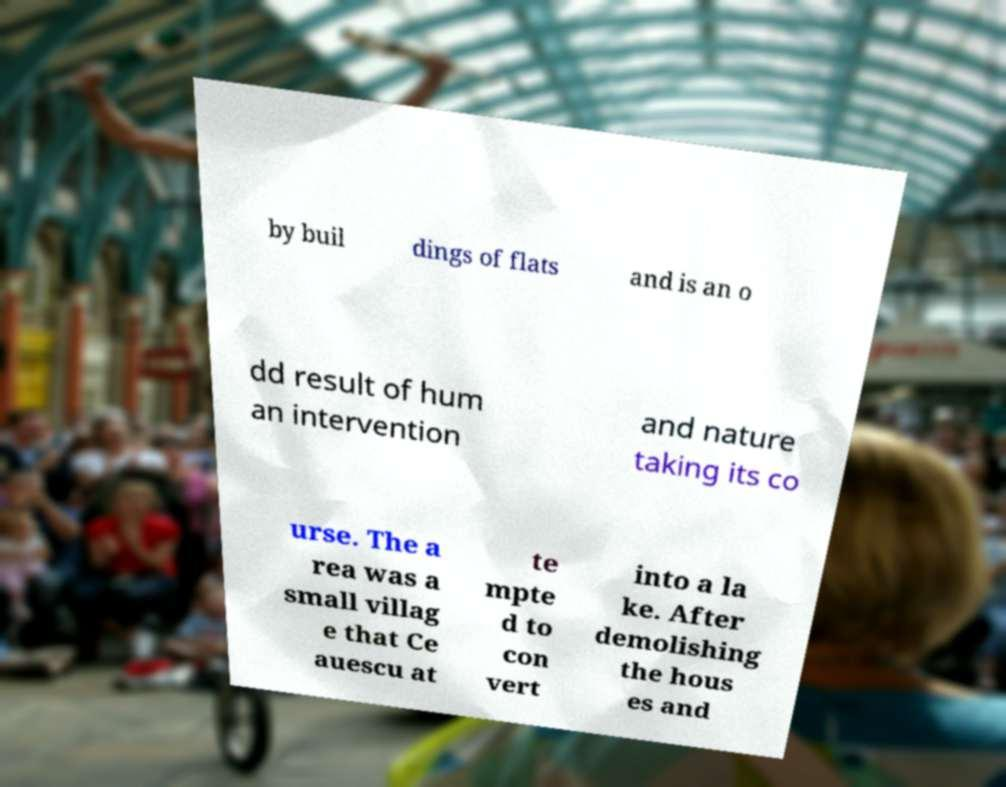Please read and relay the text visible in this image. What does it say? by buil dings of flats and is an o dd result of hum an intervention and nature taking its co urse. The a rea was a small villag e that Ce auescu at te mpte d to con vert into a la ke. After demolishing the hous es and 